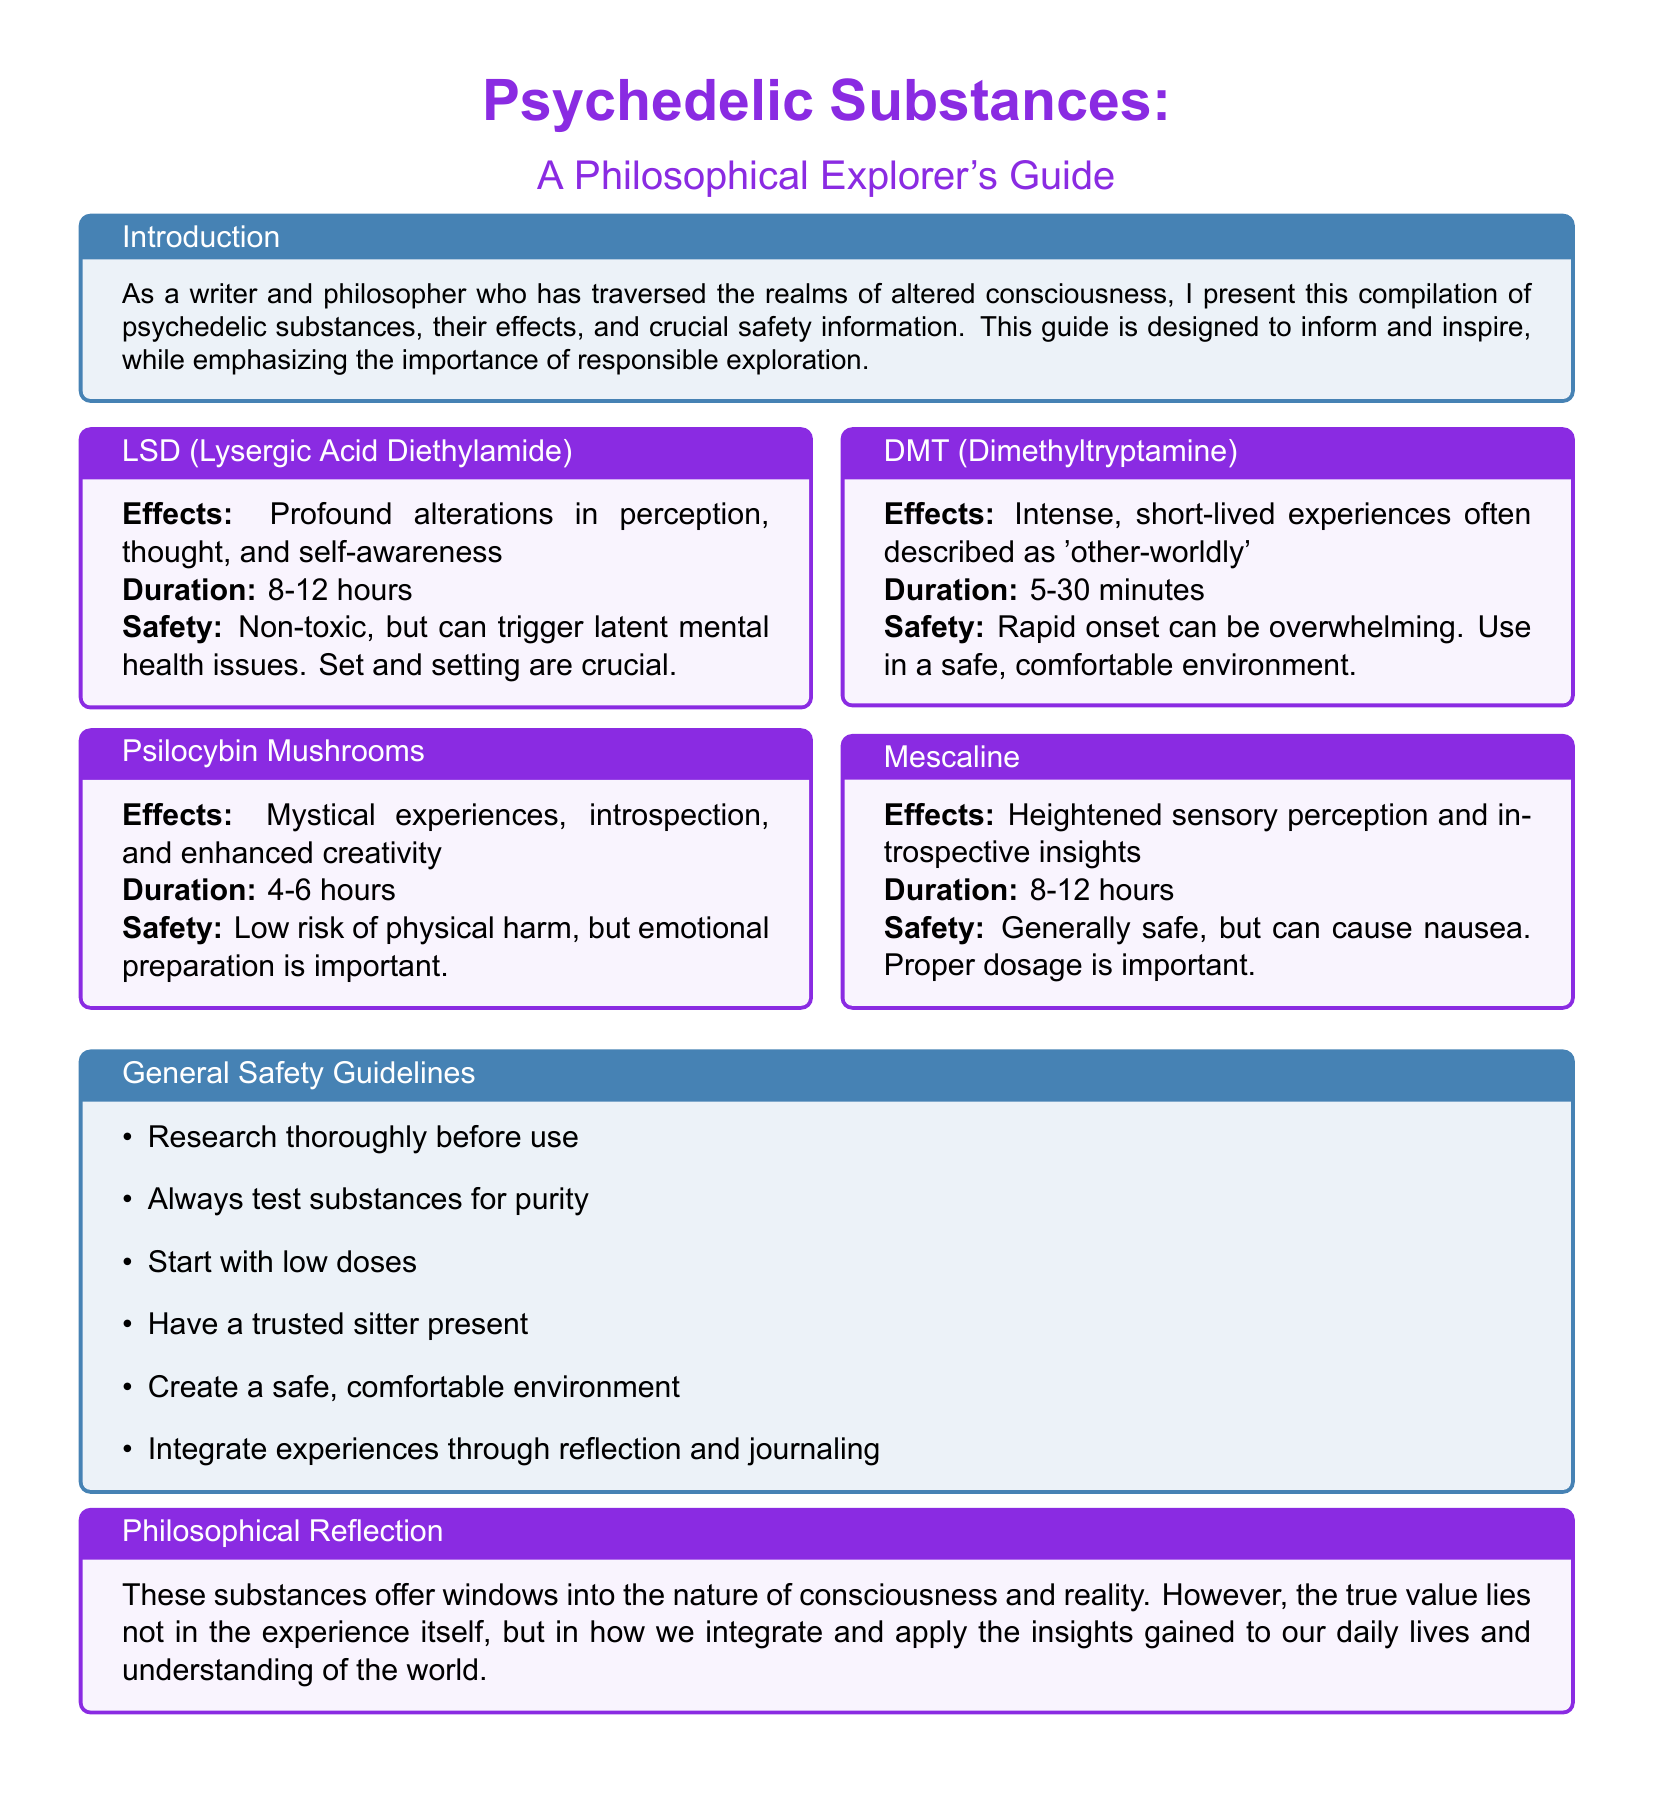What is the title of the document? The title is prominently displayed at the beginning of the document, stating the focus on psychedelic substances.
Answer: Psychedelic Substances: A Philosophical Explorer's Guide How long does a DMT experience typically last? The duration for DMT experiences is listed clearly in the document, indicating the range of time one might expect.
Answer: 5-30 minutes What are the effects of Psilocybin Mushrooms? The document provides specific effects associated with each substance, detailing Psilocybin's experiences clearly.
Answer: Mystical experiences, introspection, and enhanced creativity What safety guideline emphasizes having someone present? One of the guidelines highlights the importance of having support during the experience, ensuring safety.
Answer: Have a trusted sitter present How long do effects of LSD last? The document specifies the duration of effects for each substance, which informs readers about their experiences.
Answer: 8-12 hours What is the primary risk associated with LSD use? The document identifies potential mental health triggers related to LSD, which is vital for users to consider.
Answer: Can trigger latent mental health issues What type of experience is described for Mescaline? The document outlines specific experiences related to Mescaline, which helps users understand its effects.
Answer: Heightened sensory perception and introspective insights What is emphasized about the integration of psychedelic experiences? The document reflects on the philosophical importance of understanding and applying insights gained from experiences, which guides responsible use.
Answer: Integrate experiences through reflection and journaling 